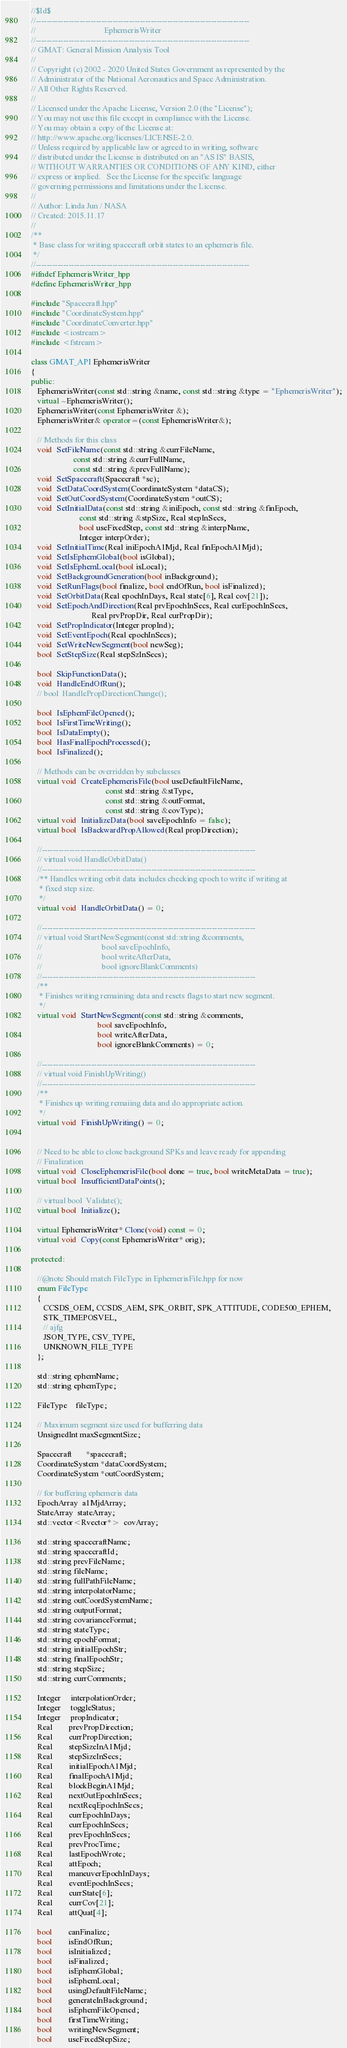Convert code to text. <code><loc_0><loc_0><loc_500><loc_500><_C++_>//$Id$
//------------------------------------------------------------------------------
//                                  EphemerisWriter
//------------------------------------------------------------------------------
// GMAT: General Mission Analysis Tool
//
// Copyright (c) 2002 - 2020 United States Government as represented by the
// Administrator of the National Aeronautics and Space Administration.
// All Other Rights Reserved.
//
// Licensed under the Apache License, Version 2.0 (the "License"); 
// You may not use this file except in compliance with the License. 
// You may obtain a copy of the License at:
// http://www.apache.org/licenses/LICENSE-2.0. 
// Unless required by applicable law or agreed to in writing, software
// distributed under the License is distributed on an "AS IS" BASIS,
// WITHOUT WARRANTIES OR CONDITIONS OF ANY KIND, either 
// express or implied.   See the License for the specific language
// governing permissions and limitations under the License.
//
// Author: Linda Jun / NASA
// Created: 2015.11.17
//
/**
 * Base class for writing spacecraft orbit states to an ephemeris file.
 */
//------------------------------------------------------------------------------
#ifndef EphemerisWriter_hpp
#define EphemerisWriter_hpp

#include "Spacecraft.hpp"
#include "CoordinateSystem.hpp"
#include "CoordinateConverter.hpp"
#include <iostream>
#include <fstream>

class GMAT_API EphemerisWriter
{
public:
   EphemerisWriter(const std::string &name, const std::string &type = "EphemerisWriter");
   virtual ~EphemerisWriter();
   EphemerisWriter(const EphemerisWriter &);
   EphemerisWriter& operator=(const EphemerisWriter&);
   
   // Methods for this class
   void  SetFileName(const std::string &currFileName,
                     const std::string &currFullName,
                     const std::string &prevFullName);
   void  SetSpacecraft(Spacecraft *sc);
   void  SetDataCoordSystem(CoordinateSystem *dataCS);
   void  SetOutCoordSystem(CoordinateSystem *outCS);
   void  SetInitialData(const std::string &iniEpoch, const std::string &finEpoch,
                        const std::string &stpSize, Real stepInSecs,
                        bool useFixedStep, const std::string &interpName,
                        Integer interpOrder);
   void  SetInitialTime(Real iniEpochA1Mjd, Real finEpochA1Mjd);
   void  SetIsEphemGlobal(bool isGlobal);
   void  SetIsEphemLocal(bool isLocal);
   void  SetBackgroundGeneration(bool inBackground);
   void  SetRunFlags(bool finalize, bool endOfRun, bool isFinalized);
   void  SetOrbitData(Real epochInDays, Real state[6], Real cov[21]);
   void  SetEpochAndDirection(Real prvEpochInSecs, Real curEpochInSecs,
                              Real prvPropDir, Real curPropDir);
   void  SetPropIndicator(Integer propInd);
   void  SetEventEpoch(Real epochInSecs);
   void  SetWriteNewSegment(bool newSeg);
   bool  SetStepSize(Real stepSzInSecs);
   
   bool  SkipFunctionData();
   void  HandleEndOfRun();
   // bool  HandlePropDirectionChange();
   
   bool  IsEphemFileOpened();
   bool  IsFirstTimeWriting();
   bool  IsDataEmpty();
   bool  HasFinalEpochProcessed();
   bool  IsFinalized();
   
   // Methods can be overridden by subclasses
   virtual void  CreateEphemerisFile(bool useDefaultFileName,
                                     const std::string &stType,
                                     const std::string &outFormat,
                                     const std::string &covType);
   virtual void  InitializeData(bool saveEpochInfo = false);
   virtual bool  IsBackwardPropAllowed(Real propDirection);
   
   //------------------------------------------------------------------------------
   // virtual void HandleOrbitData()
   //------------------------------------------------------------------------------
   /** Handles writing orbit data includes checking epoch to write if writing at
    * fixed step size.
    */
   virtual void  HandleOrbitData() = 0;
   
   //------------------------------------------------------------------------------
   // virtual void StartNewSegment(const std::string &comments,
   //                              bool saveEpochInfo,
   //                              bool writeAfterData,
   //                              bool ignoreBlankComments)
   //------------------------------------------------------------------------------
   /**
    * Finishes writing remaining data and resets flags to start new segment.
    */
   virtual void  StartNewSegment(const std::string &comments,
                                 bool saveEpochInfo,
                                 bool writeAfterData,
                                 bool ignoreBlankComments) = 0;
   
   //------------------------------------------------------------------------------
   // virtual void FinishUpWriting()
   //------------------------------------------------------------------------------
   /**
    * Finishes up writing remaiing data and do appropriate action.
    */
   virtual void  FinishUpWriting() = 0;

   
   // Need to be able to close background SPKs and leave ready for appending
   // Finalization
   virtual void  CloseEphemerisFile(bool done = true, bool writeMetaData = true);
   virtual bool  InsufficientDataPoints();
   
   // virtual bool  Validate();
   virtual bool  Initialize();
   
   virtual EphemerisWriter* Clone(void) const = 0;
   virtual void  Copy(const EphemerisWriter* orig);
   
protected:

   //@note Should match FileType in EphemerisFile.hpp for now
   enum FileType
   {
      CCSDS_OEM, CCSDS_AEM, SPK_ORBIT, SPK_ATTITUDE, CODE500_EPHEM,
      STK_TIMEPOSVEL,
      // ajfg
      JSON_TYPE, CSV_TYPE,
      UNKNOWN_FILE_TYPE
   };
   
   std::string ephemName;
   std::string ephemType;
   
   FileType    fileType;

   // Maximum segment size used for bufferring data
   UnsignedInt maxSegmentSize;
   
   Spacecraft       *spacecraft;
   CoordinateSystem *dataCoordSystem;
   CoordinateSystem *outCoordSystem;
   
   // for buffering ephemeris data
   EpochArray  a1MjdArray;
   StateArray  stateArray;
   std::vector<Rvector*>  covArray;
   
   std::string spacecraftName;
   std::string spacecraftId;
   std::string prevFileName;
   std::string fileName;
   std::string fullPathFileName;
   std::string interpolatorName;
   std::string outCoordSystemName;
   std::string outputFormat;
   std::string covarianceFormat;
   std::string stateType;
   std::string epochFormat;
   std::string initialEpochStr;
   std::string finalEpochStr;
   std::string stepSize;
   std::string currComments;

   Integer     interpolationOrder;
   Integer     toggleStatus;
   Integer     propIndicator;
   Real        prevPropDirection;
   Real        currPropDirection;
   Real        stepSizeInA1Mjd;
   Real        stepSizeInSecs;
   Real        initialEpochA1Mjd;
   Real        finalEpochA1Mjd;
   Real        blockBeginA1Mjd;
   Real        nextOutEpochInSecs;
   Real        nextReqEpochInSecs;
   Real        currEpochInDays;
   Real        currEpochInSecs;
   Real        prevEpochInSecs;
   Real        prevProcTime;
   Real        lastEpochWrote;
   Real        attEpoch;
   Real        maneuverEpochInDays;
   Real        eventEpochInSecs;
   Real        currState[6];
   Real        currCov[21];
   Real        attQuat[4];

   bool        canFinalize;
   bool        isEndOfRun;
   bool        isInitialized;
   bool        isFinalized;
   bool        isEphemGlobal;
   bool        isEphemLocal;
   bool        usingDefaultFileName;
   bool        generateInBackground;
   bool        isEphemFileOpened;
   bool        firstTimeWriting;
   bool        writingNewSegment;
   bool        useFixedStepSize;</code> 